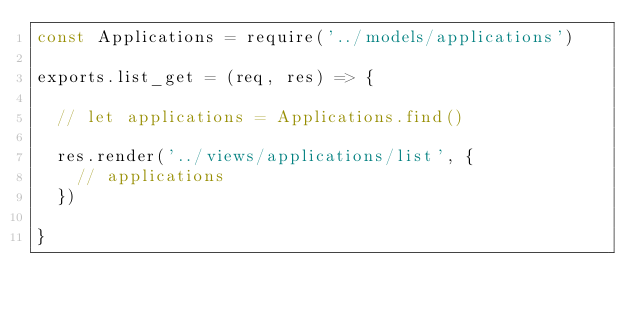Convert code to text. <code><loc_0><loc_0><loc_500><loc_500><_JavaScript_>const Applications = require('../models/applications')

exports.list_get = (req, res) => {

  // let applications = Applications.find()

  res.render('../views/applications/list', {
    // applications
  })

}
</code> 